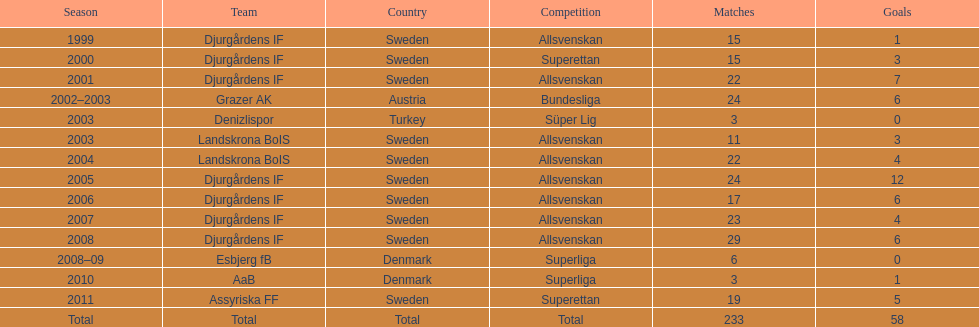In what season are the most goals scored? 2005. 